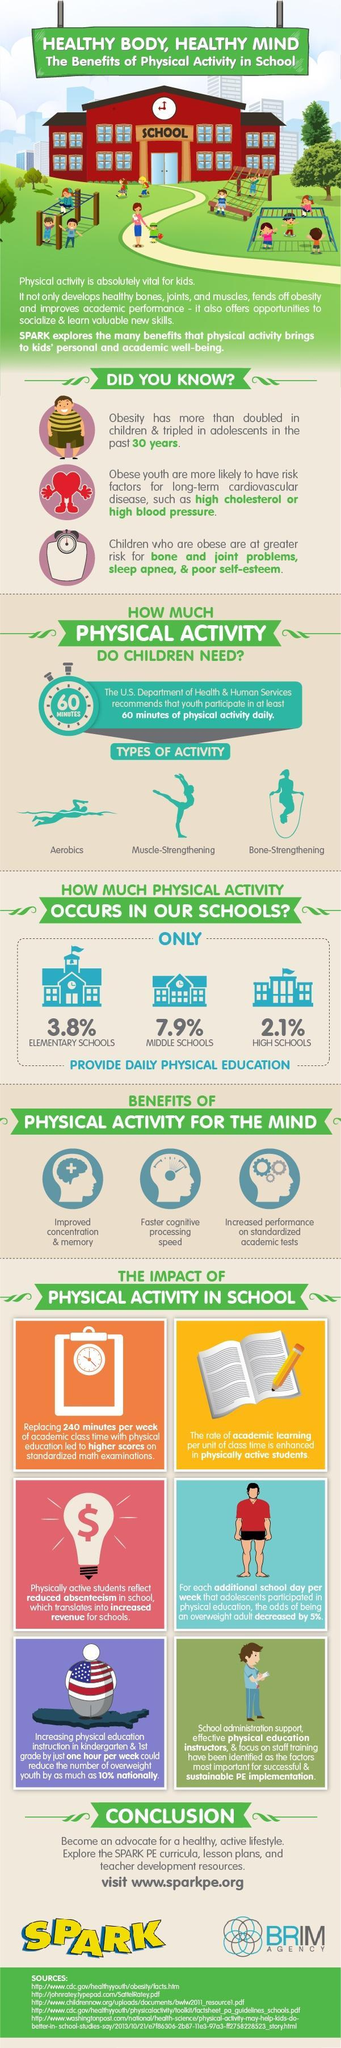How many sources are listed at the bottom?
Answer the question with a short phrase. 5 